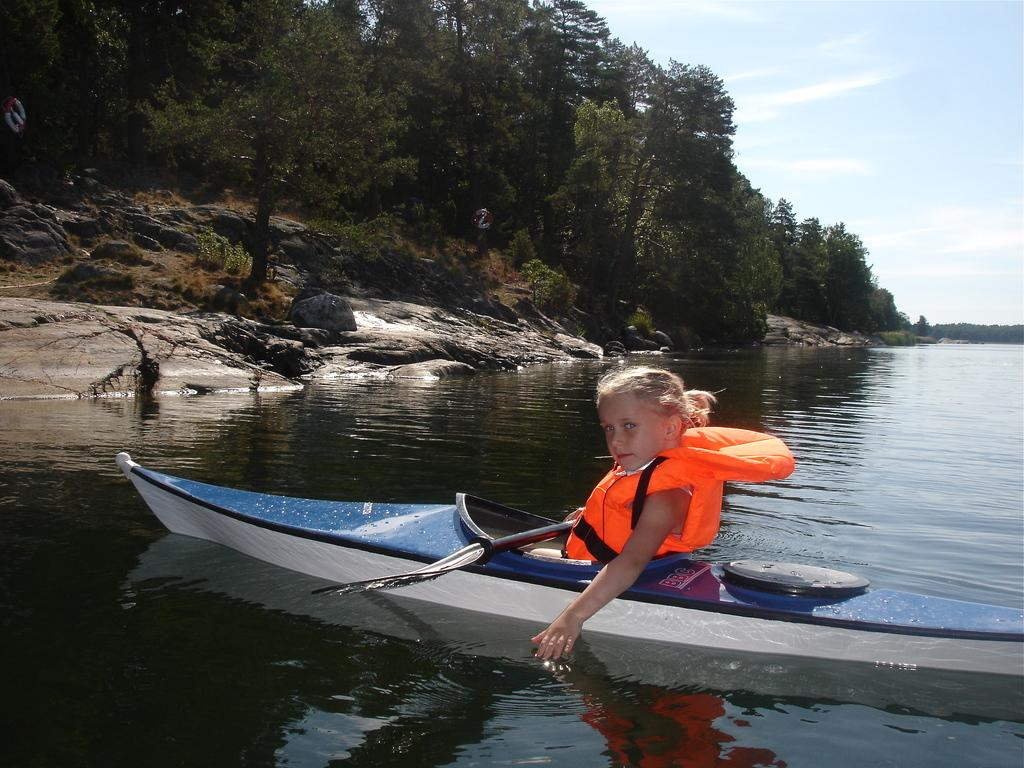Who is the main subject in the image? There is a girl in the image. What is the girl doing in the image? The girl is rowing a boat. What safety precaution is the girl taking while rowing the boat? The girl is wearing a life jacket. What can be seen on the left side of the image? There are trees on the left side of the image. What is visible at the top of the image? The sky is visible at the top of the image. How does the crowd react to the girl rowing the boat in the image? There is no crowd present in the image, so it is not possible to determine how they might react. 